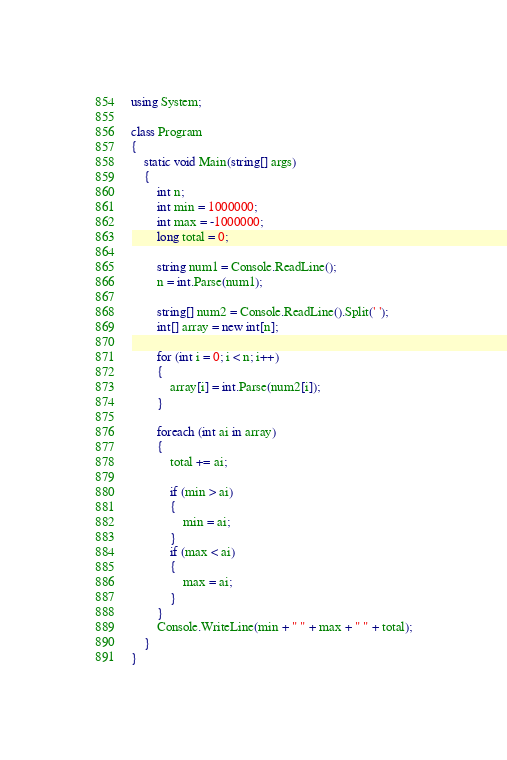<code> <loc_0><loc_0><loc_500><loc_500><_C#_>using System;

class Program
{
    static void Main(string[] args)
    {
        int n;
        int min = 1000000;
        int max = -1000000;
        long total = 0;

        string num1 = Console.ReadLine();
        n = int.Parse(num1);

        string[] num2 = Console.ReadLine().Split(' ');
        int[] array = new int[n];

        for (int i = 0; i < n; i++)
        {
            array[i] = int.Parse(num2[i]);
        }
            
        foreach (int ai in array)
        {
            total += ai;

            if (min > ai)
            {
                min = ai;
            }
            if (max < ai)
            {
                max = ai;
            }
        }
        Console.WriteLine(min + " " + max + " " + total);
    }
}
</code> 